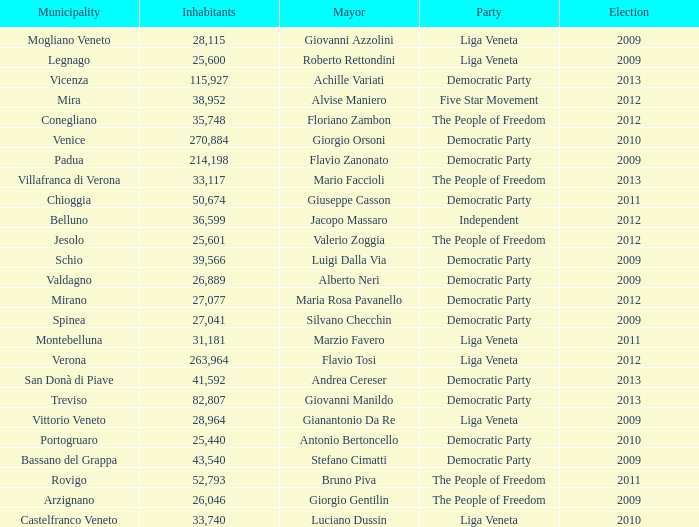What party was achille variati afilliated with? Democratic Party. 